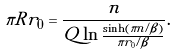<formula> <loc_0><loc_0><loc_500><loc_500>\pi R r _ { 0 } = \frac { n } { Q \ln \frac { \sinh ( \pi n / \beta ) } { \pi r _ { 0 } / \beta } } .</formula> 